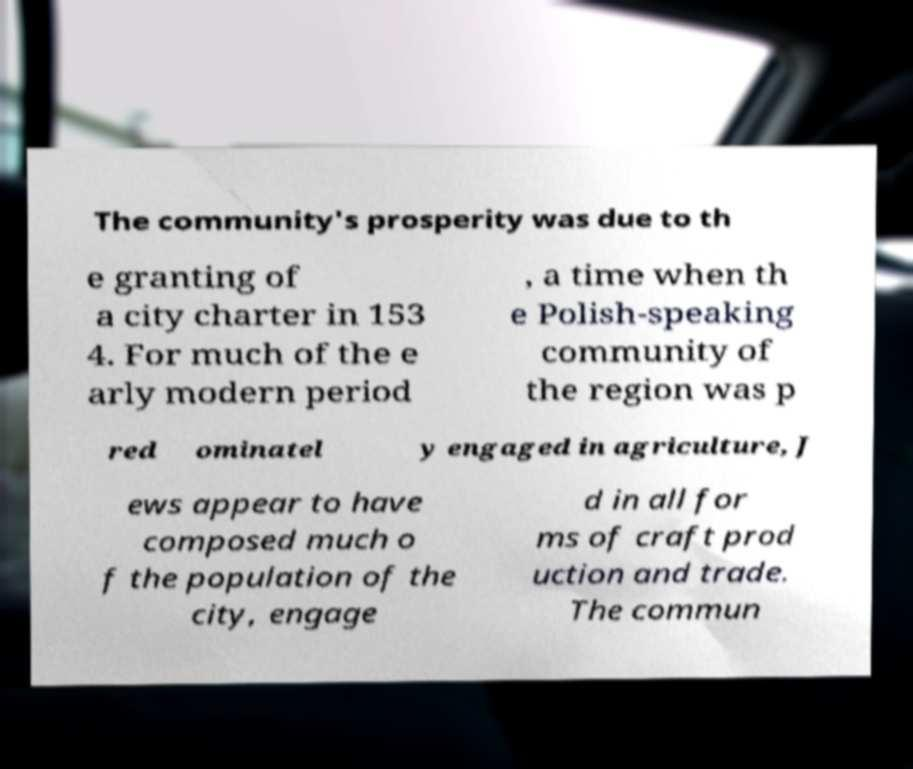Could you assist in decoding the text presented in this image and type it out clearly? The community's prosperity was due to th e granting of a city charter in 153 4. For much of the e arly modern period , a time when th e Polish-speaking community of the region was p red ominatel y engaged in agriculture, J ews appear to have composed much o f the population of the city, engage d in all for ms of craft prod uction and trade. The commun 